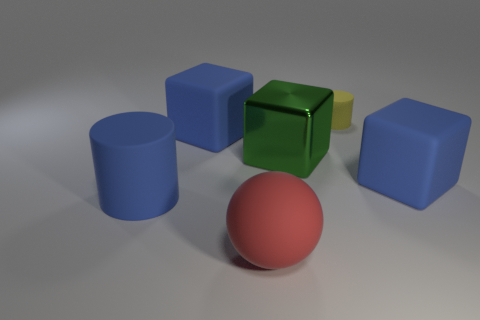Subtract all green metal blocks. How many blocks are left? 2 Add 2 tiny yellow objects. How many objects exist? 8 Subtract all red cylinders. How many blue blocks are left? 2 Subtract all blue blocks. How many blocks are left? 1 Subtract all cylinders. How many objects are left? 4 Add 4 tiny rubber cylinders. How many tiny rubber cylinders are left? 5 Add 5 blue cylinders. How many blue cylinders exist? 6 Subtract 0 purple cubes. How many objects are left? 6 Subtract all gray blocks. Subtract all green cylinders. How many blocks are left? 3 Subtract all blue matte cylinders. Subtract all big red matte spheres. How many objects are left? 4 